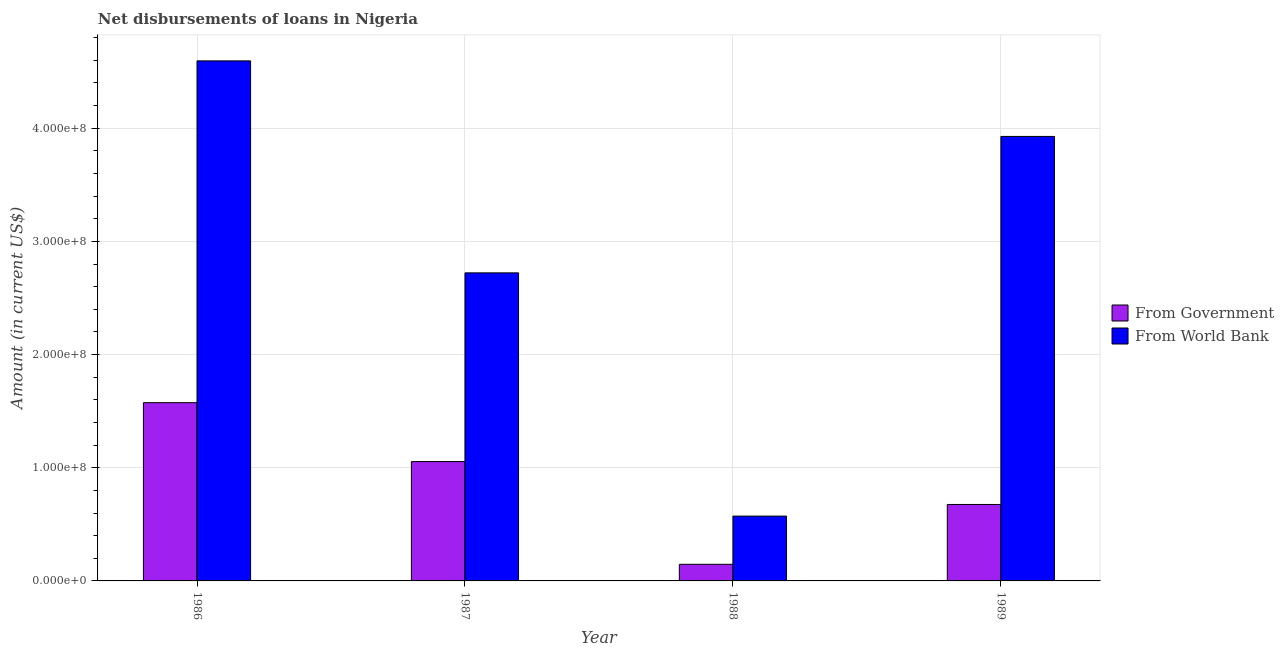How many different coloured bars are there?
Your answer should be compact. 2. How many groups of bars are there?
Ensure brevity in your answer.  4. Are the number of bars on each tick of the X-axis equal?
Make the answer very short. Yes. How many bars are there on the 2nd tick from the left?
Ensure brevity in your answer.  2. How many bars are there on the 1st tick from the right?
Give a very brief answer. 2. In how many cases, is the number of bars for a given year not equal to the number of legend labels?
Your response must be concise. 0. What is the net disbursements of loan from government in 1988?
Your response must be concise. 1.47e+07. Across all years, what is the maximum net disbursements of loan from government?
Ensure brevity in your answer.  1.58e+08. Across all years, what is the minimum net disbursements of loan from government?
Offer a very short reply. 1.47e+07. What is the total net disbursements of loan from government in the graph?
Offer a very short reply. 3.45e+08. What is the difference between the net disbursements of loan from government in 1986 and that in 1987?
Your response must be concise. 5.20e+07. What is the difference between the net disbursements of loan from world bank in 1986 and the net disbursements of loan from government in 1987?
Make the answer very short. 1.87e+08. What is the average net disbursements of loan from world bank per year?
Offer a terse response. 2.95e+08. In the year 1989, what is the difference between the net disbursements of loan from government and net disbursements of loan from world bank?
Give a very brief answer. 0. In how many years, is the net disbursements of loan from government greater than 400000000 US$?
Ensure brevity in your answer.  0. What is the ratio of the net disbursements of loan from government in 1986 to that in 1989?
Offer a terse response. 2.33. What is the difference between the highest and the second highest net disbursements of loan from world bank?
Your answer should be compact. 6.68e+07. What is the difference between the highest and the lowest net disbursements of loan from government?
Provide a short and direct response. 1.43e+08. In how many years, is the net disbursements of loan from government greater than the average net disbursements of loan from government taken over all years?
Provide a short and direct response. 2. Is the sum of the net disbursements of loan from world bank in 1986 and 1987 greater than the maximum net disbursements of loan from government across all years?
Ensure brevity in your answer.  Yes. What does the 1st bar from the left in 1986 represents?
Keep it short and to the point. From Government. What does the 2nd bar from the right in 1989 represents?
Provide a short and direct response. From Government. How many bars are there?
Provide a short and direct response. 8. Are all the bars in the graph horizontal?
Ensure brevity in your answer.  No. How many years are there in the graph?
Ensure brevity in your answer.  4. What is the difference between two consecutive major ticks on the Y-axis?
Your answer should be very brief. 1.00e+08. Where does the legend appear in the graph?
Provide a short and direct response. Center right. How many legend labels are there?
Offer a very short reply. 2. How are the legend labels stacked?
Give a very brief answer. Vertical. What is the title of the graph?
Provide a short and direct response. Net disbursements of loans in Nigeria. Does "Investment in Transport" appear as one of the legend labels in the graph?
Your response must be concise. No. What is the Amount (in current US$) of From Government in 1986?
Ensure brevity in your answer.  1.58e+08. What is the Amount (in current US$) of From World Bank in 1986?
Provide a short and direct response. 4.60e+08. What is the Amount (in current US$) in From Government in 1987?
Your answer should be very brief. 1.05e+08. What is the Amount (in current US$) of From World Bank in 1987?
Give a very brief answer. 2.72e+08. What is the Amount (in current US$) in From Government in 1988?
Keep it short and to the point. 1.47e+07. What is the Amount (in current US$) of From World Bank in 1988?
Make the answer very short. 5.73e+07. What is the Amount (in current US$) in From Government in 1989?
Ensure brevity in your answer.  6.76e+07. What is the Amount (in current US$) in From World Bank in 1989?
Offer a terse response. 3.93e+08. Across all years, what is the maximum Amount (in current US$) of From Government?
Provide a succinct answer. 1.58e+08. Across all years, what is the maximum Amount (in current US$) of From World Bank?
Give a very brief answer. 4.60e+08. Across all years, what is the minimum Amount (in current US$) of From Government?
Offer a very short reply. 1.47e+07. Across all years, what is the minimum Amount (in current US$) of From World Bank?
Offer a terse response. 5.73e+07. What is the total Amount (in current US$) of From Government in the graph?
Keep it short and to the point. 3.45e+08. What is the total Amount (in current US$) in From World Bank in the graph?
Provide a succinct answer. 1.18e+09. What is the difference between the Amount (in current US$) in From Government in 1986 and that in 1987?
Offer a terse response. 5.20e+07. What is the difference between the Amount (in current US$) of From World Bank in 1986 and that in 1987?
Your response must be concise. 1.87e+08. What is the difference between the Amount (in current US$) in From Government in 1986 and that in 1988?
Keep it short and to the point. 1.43e+08. What is the difference between the Amount (in current US$) of From World Bank in 1986 and that in 1988?
Keep it short and to the point. 4.02e+08. What is the difference between the Amount (in current US$) of From Government in 1986 and that in 1989?
Give a very brief answer. 9.00e+07. What is the difference between the Amount (in current US$) in From World Bank in 1986 and that in 1989?
Your answer should be very brief. 6.68e+07. What is the difference between the Amount (in current US$) of From Government in 1987 and that in 1988?
Your answer should be very brief. 9.08e+07. What is the difference between the Amount (in current US$) in From World Bank in 1987 and that in 1988?
Keep it short and to the point. 2.15e+08. What is the difference between the Amount (in current US$) in From Government in 1987 and that in 1989?
Give a very brief answer. 3.79e+07. What is the difference between the Amount (in current US$) in From World Bank in 1987 and that in 1989?
Keep it short and to the point. -1.21e+08. What is the difference between the Amount (in current US$) in From Government in 1988 and that in 1989?
Offer a terse response. -5.29e+07. What is the difference between the Amount (in current US$) in From World Bank in 1988 and that in 1989?
Your response must be concise. -3.36e+08. What is the difference between the Amount (in current US$) in From Government in 1986 and the Amount (in current US$) in From World Bank in 1987?
Offer a terse response. -1.15e+08. What is the difference between the Amount (in current US$) of From Government in 1986 and the Amount (in current US$) of From World Bank in 1988?
Keep it short and to the point. 1.00e+08. What is the difference between the Amount (in current US$) in From Government in 1986 and the Amount (in current US$) in From World Bank in 1989?
Provide a short and direct response. -2.35e+08. What is the difference between the Amount (in current US$) of From Government in 1987 and the Amount (in current US$) of From World Bank in 1988?
Offer a terse response. 4.82e+07. What is the difference between the Amount (in current US$) in From Government in 1987 and the Amount (in current US$) in From World Bank in 1989?
Give a very brief answer. -2.87e+08. What is the difference between the Amount (in current US$) in From Government in 1988 and the Amount (in current US$) in From World Bank in 1989?
Ensure brevity in your answer.  -3.78e+08. What is the average Amount (in current US$) in From Government per year?
Make the answer very short. 8.63e+07. What is the average Amount (in current US$) of From World Bank per year?
Give a very brief answer. 2.95e+08. In the year 1986, what is the difference between the Amount (in current US$) in From Government and Amount (in current US$) in From World Bank?
Ensure brevity in your answer.  -3.02e+08. In the year 1987, what is the difference between the Amount (in current US$) of From Government and Amount (in current US$) of From World Bank?
Provide a short and direct response. -1.67e+08. In the year 1988, what is the difference between the Amount (in current US$) in From Government and Amount (in current US$) in From World Bank?
Ensure brevity in your answer.  -4.26e+07. In the year 1989, what is the difference between the Amount (in current US$) of From Government and Amount (in current US$) of From World Bank?
Your answer should be very brief. -3.25e+08. What is the ratio of the Amount (in current US$) in From Government in 1986 to that in 1987?
Your answer should be compact. 1.49. What is the ratio of the Amount (in current US$) of From World Bank in 1986 to that in 1987?
Offer a terse response. 1.69. What is the ratio of the Amount (in current US$) of From Government in 1986 to that in 1988?
Provide a succinct answer. 10.73. What is the ratio of the Amount (in current US$) of From World Bank in 1986 to that in 1988?
Provide a succinct answer. 8.02. What is the ratio of the Amount (in current US$) in From Government in 1986 to that in 1989?
Offer a terse response. 2.33. What is the ratio of the Amount (in current US$) of From World Bank in 1986 to that in 1989?
Provide a succinct answer. 1.17. What is the ratio of the Amount (in current US$) in From Government in 1987 to that in 1988?
Provide a succinct answer. 7.19. What is the ratio of the Amount (in current US$) in From World Bank in 1987 to that in 1988?
Make the answer very short. 4.75. What is the ratio of the Amount (in current US$) of From Government in 1987 to that in 1989?
Ensure brevity in your answer.  1.56. What is the ratio of the Amount (in current US$) of From World Bank in 1987 to that in 1989?
Offer a terse response. 0.69. What is the ratio of the Amount (in current US$) of From Government in 1988 to that in 1989?
Provide a short and direct response. 0.22. What is the ratio of the Amount (in current US$) in From World Bank in 1988 to that in 1989?
Offer a very short reply. 0.15. What is the difference between the highest and the second highest Amount (in current US$) of From Government?
Your answer should be very brief. 5.20e+07. What is the difference between the highest and the second highest Amount (in current US$) in From World Bank?
Your answer should be compact. 6.68e+07. What is the difference between the highest and the lowest Amount (in current US$) in From Government?
Provide a short and direct response. 1.43e+08. What is the difference between the highest and the lowest Amount (in current US$) of From World Bank?
Provide a succinct answer. 4.02e+08. 